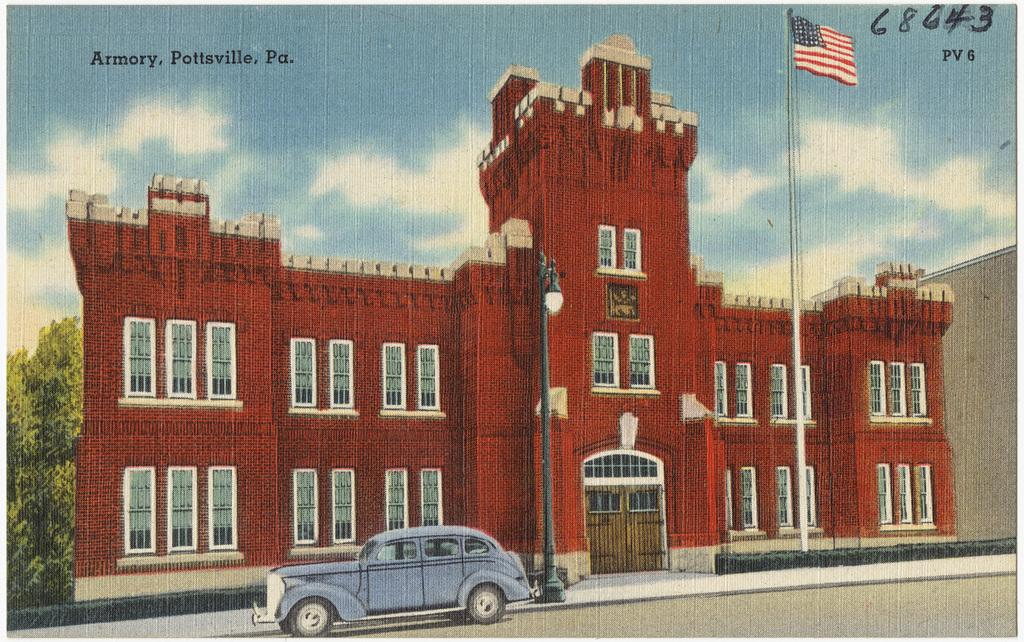What type of structure is shown in the image? There is a building depicted in the image. What mode of transportation can be seen in the image? There is a car in the image. What type of lighting is present in the image? A street light is present in the image. What type of plant is visible in the image? There is a tree in the image. What symbol or emblem is shown in the image? There is a flag in the image. What type of steel is used to construct the car in the image? There is no mention of steel in the image, and the car's construction material is not specified. How does the clam contribute to the image? There is no clam present in the image. 